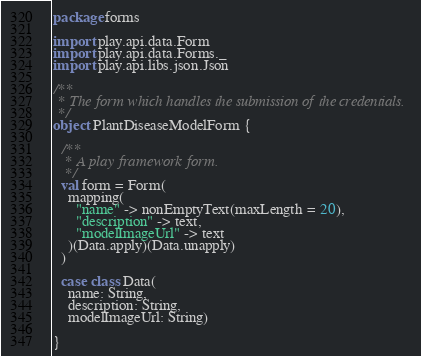<code> <loc_0><loc_0><loc_500><loc_500><_Scala_>package forms

import play.api.data.Form
import play.api.data.Forms._
import play.api.libs.json.Json

/**
 * The form which handles the submission of the credentials.
 */
object PlantDiseaseModelForm {

  /**
   * A play framework form.
   */
  val form = Form(
    mapping(
      "name" -> nonEmptyText(maxLength = 20),
      "description" -> text,
      "modelImageUrl" -> text
    )(Data.apply)(Data.unapply)
  )

  case class Data(
    name: String,
    description: String,
    modelImageUrl: String)

}
</code> 